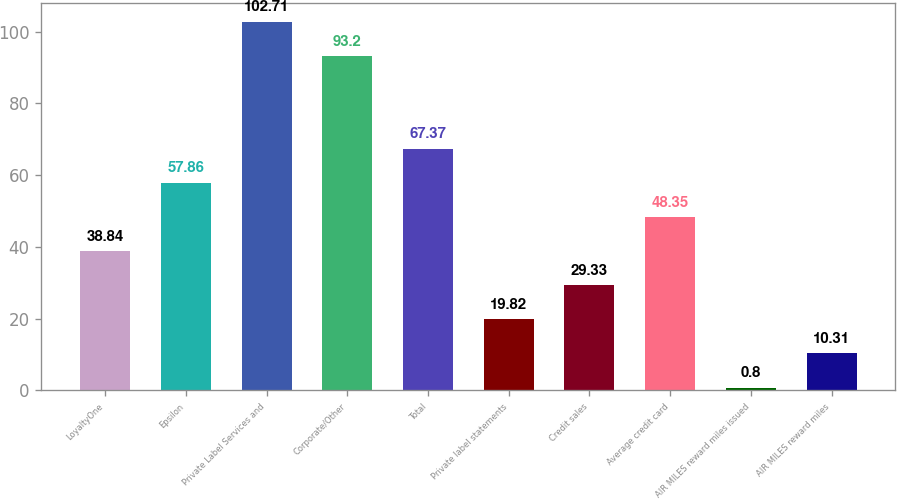Convert chart. <chart><loc_0><loc_0><loc_500><loc_500><bar_chart><fcel>LoyaltyOne<fcel>Epsilon<fcel>Private Label Services and<fcel>Corporate/Other<fcel>Total<fcel>Private label statements<fcel>Credit sales<fcel>Average credit card<fcel>AIR MILES reward miles issued<fcel>AIR MILES reward miles<nl><fcel>38.84<fcel>57.86<fcel>102.71<fcel>93.2<fcel>67.37<fcel>19.82<fcel>29.33<fcel>48.35<fcel>0.8<fcel>10.31<nl></chart> 